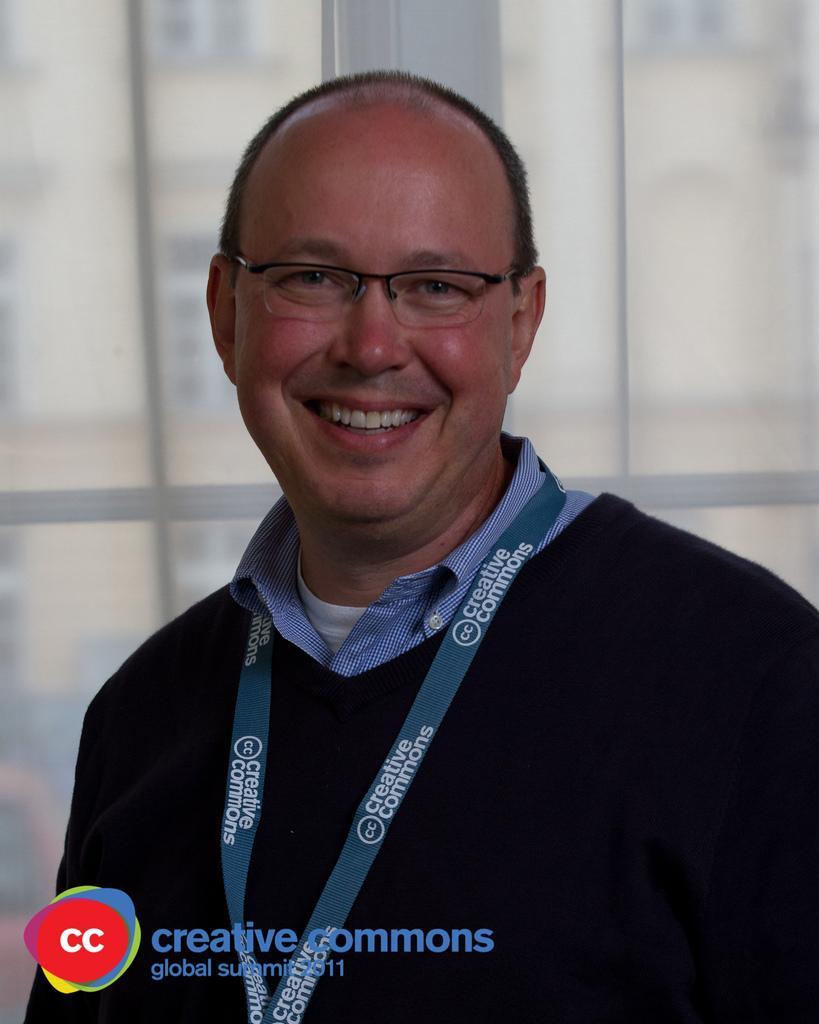Describe this image in one or two sentences. In this picture I can see there is a man standing and smiling he is wearing spectacles and a coat. 